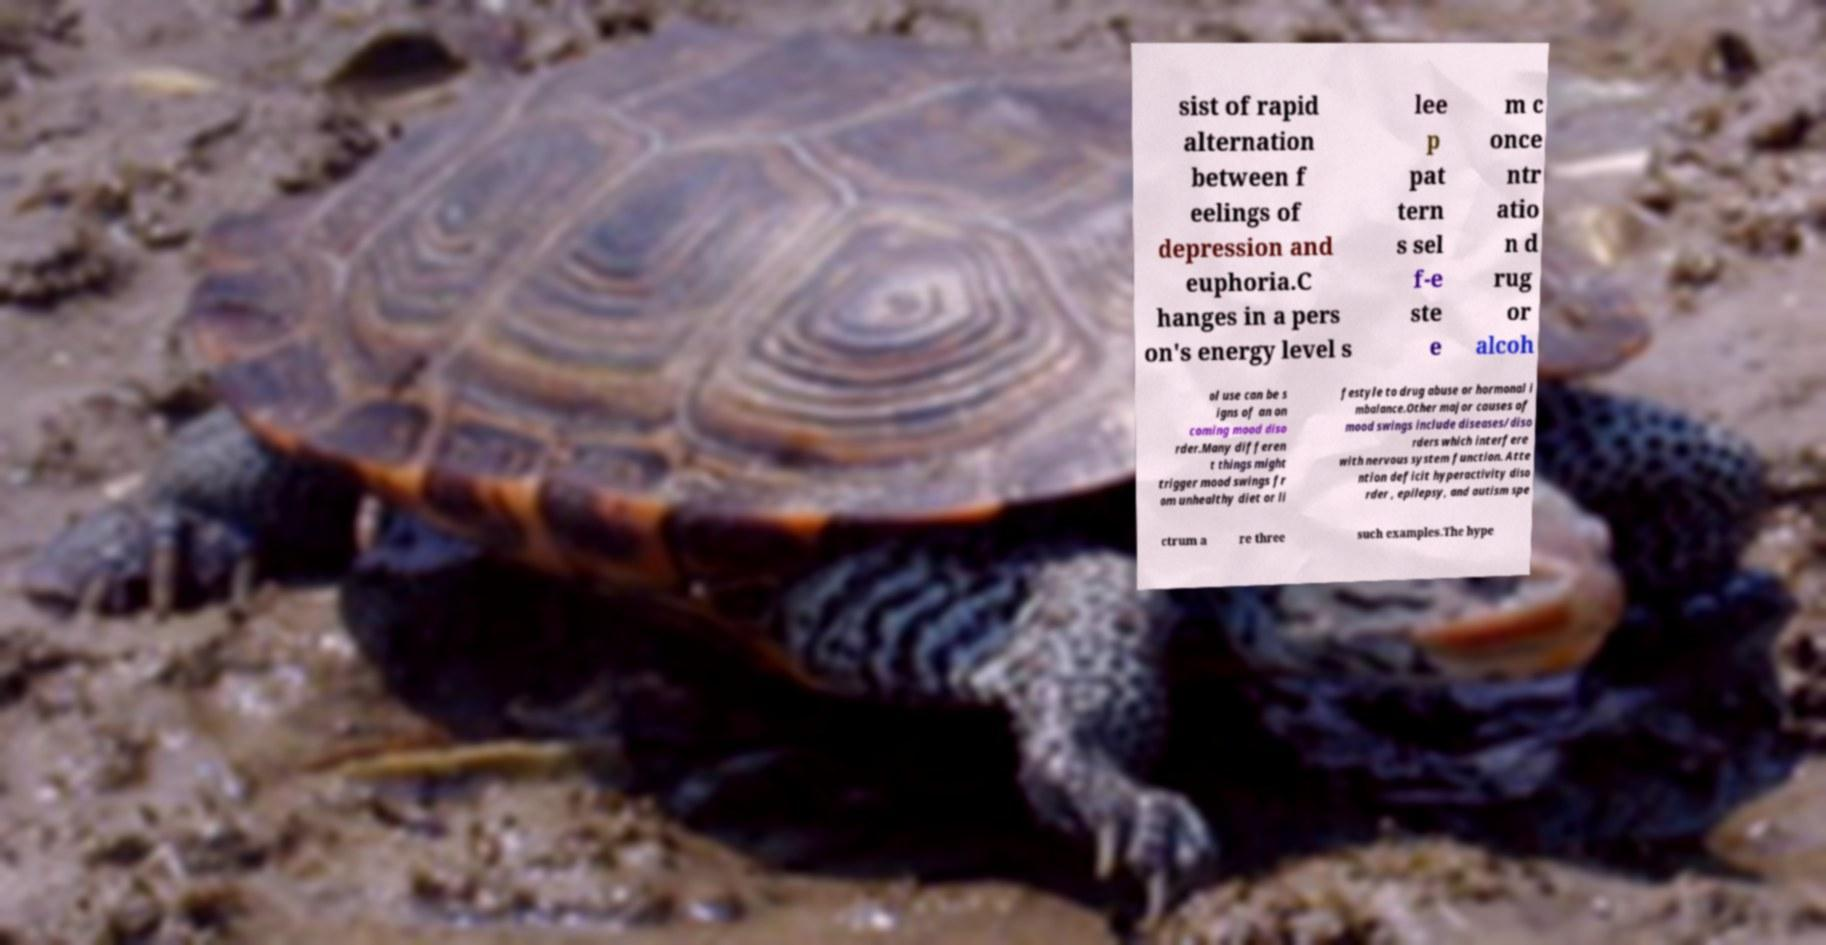What messages or text are displayed in this image? I need them in a readable, typed format. sist of rapid alternation between f eelings of depression and euphoria.C hanges in a pers on's energy level s lee p pat tern s sel f-e ste e m c once ntr atio n d rug or alcoh ol use can be s igns of an on coming mood diso rder.Many differen t things might trigger mood swings fr om unhealthy diet or li festyle to drug abuse or hormonal i mbalance.Other major causes of mood swings include diseases/diso rders which interfere with nervous system function. Atte ntion deficit hyperactivity diso rder , epilepsy, and autism spe ctrum a re three such examples.The hype 